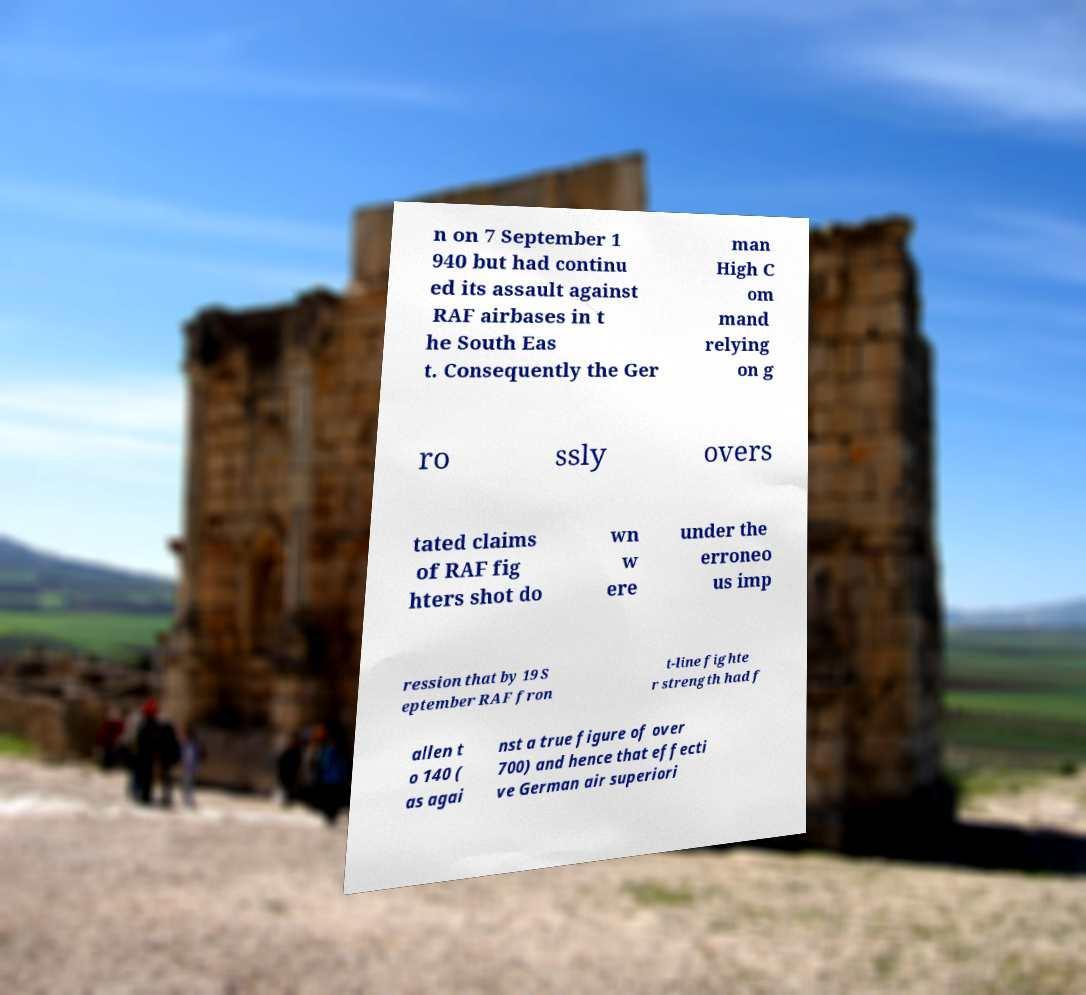What messages or text are displayed in this image? I need them in a readable, typed format. n on 7 September 1 940 but had continu ed its assault against RAF airbases in t he South Eas t. Consequently the Ger man High C om mand relying on g ro ssly overs tated claims of RAF fig hters shot do wn w ere under the erroneo us imp ression that by 19 S eptember RAF fron t-line fighte r strength had f allen t o 140 ( as agai nst a true figure of over 700) and hence that effecti ve German air superiori 